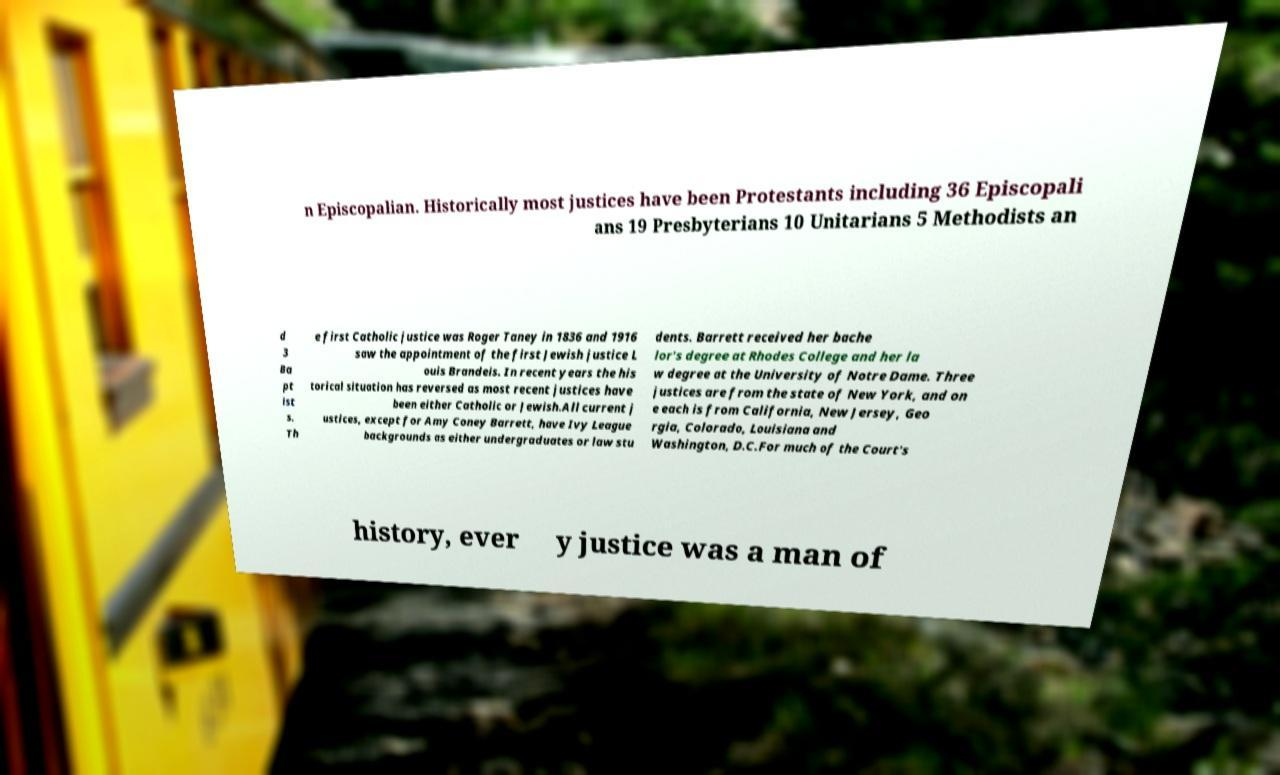For documentation purposes, I need the text within this image transcribed. Could you provide that? n Episcopalian. Historically most justices have been Protestants including 36 Episcopali ans 19 Presbyterians 10 Unitarians 5 Methodists an d 3 Ba pt ist s. Th e first Catholic justice was Roger Taney in 1836 and 1916 saw the appointment of the first Jewish justice L ouis Brandeis. In recent years the his torical situation has reversed as most recent justices have been either Catholic or Jewish.All current j ustices, except for Amy Coney Barrett, have Ivy League backgrounds as either undergraduates or law stu dents. Barrett received her bache lor's degree at Rhodes College and her la w degree at the University of Notre Dame. Three justices are from the state of New York, and on e each is from California, New Jersey, Geo rgia, Colorado, Louisiana and Washington, D.C.For much of the Court's history, ever y justice was a man of 